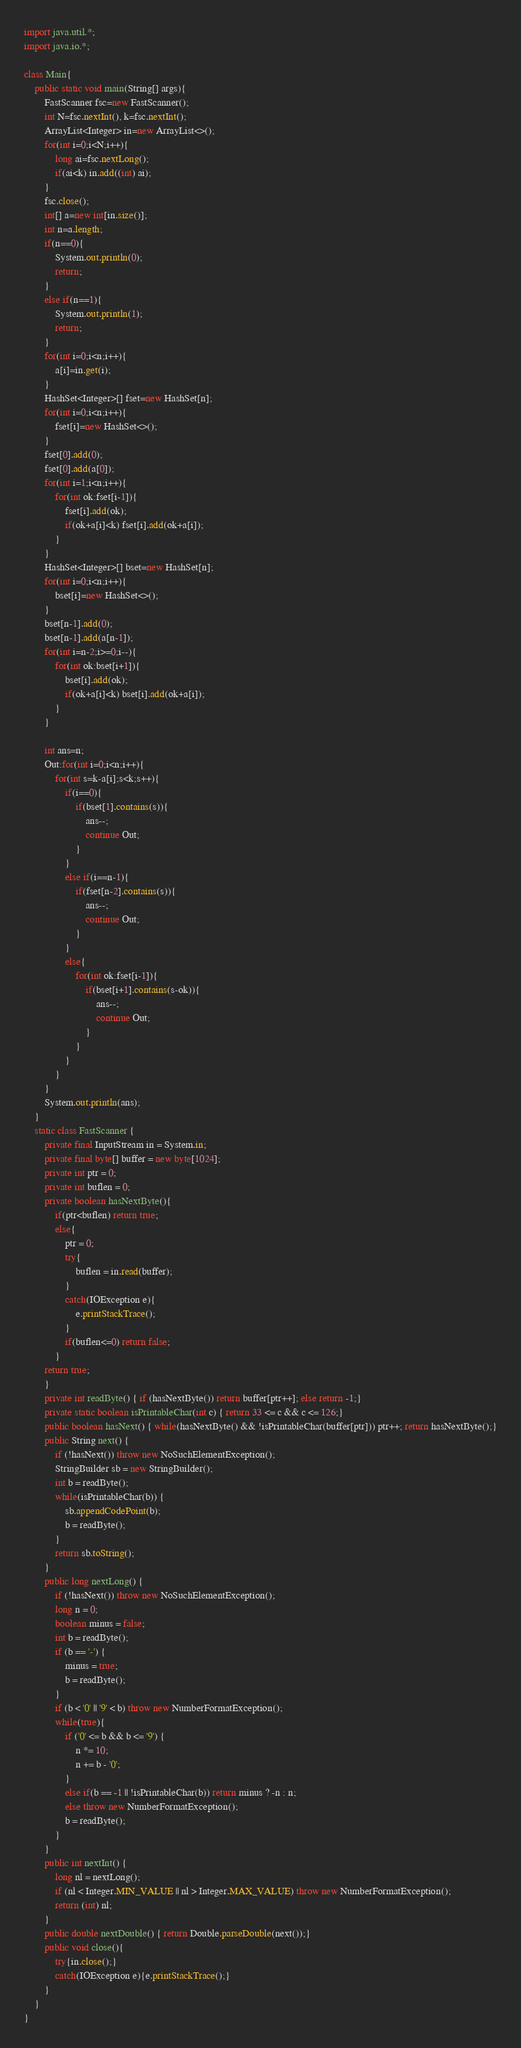<code> <loc_0><loc_0><loc_500><loc_500><_Java_>import java.util.*;
import java.io.*;

class Main{
    public static void main(String[] args){
        FastScanner fsc=new FastScanner();
        int N=fsc.nextInt(), k=fsc.nextInt();
        ArrayList<Integer> in=new ArrayList<>();
        for(int i=0;i<N;i++){
            long ai=fsc.nextLong();
            if(ai<k) in.add((int) ai);
        }
        fsc.close();
        int[] a=new int[in.size()];
        int n=a.length;
        if(n==0){
            System.out.println(0);
            return;
        }
        else if(n==1){
            System.out.println(1);
            return;
        }
        for(int i=0;i<n;i++){
            a[i]=in.get(i);
        }
        HashSet<Integer>[] fset=new HashSet[n];
        for(int i=0;i<n;i++){
            fset[i]=new HashSet<>();
        }
        fset[0].add(0);
        fset[0].add(a[0]);
        for(int i=1;i<n;i++){
            for(int ok:fset[i-1]){
                fset[i].add(ok);
                if(ok+a[i]<k) fset[i].add(ok+a[i]);
            }
        }
        HashSet<Integer>[] bset=new HashSet[n];
        for(int i=0;i<n;i++){
            bset[i]=new HashSet<>();
        }
        bset[n-1].add(0);
        bset[n-1].add(a[n-1]);
        for(int i=n-2;i>=0;i--){
            for(int ok:bset[i+1]){
                bset[i].add(ok);
                if(ok+a[i]<k) bset[i].add(ok+a[i]);
            }
        }

        int ans=n;
        Out:for(int i=0;i<n;i++){
            for(int s=k-a[i];s<k;s++){
                if(i==0){
                    if(bset[1].contains(s)){
                        ans--;
                        continue Out;
                    }
                }
                else if(i==n-1){
                    if(fset[n-2].contains(s)){
                        ans--;
                        continue Out;
                    }
                }
                else{
                    for(int ok:fset[i-1]){
                        if(bset[i+1].contains(s-ok)){
                            ans--;
                            continue Out;
                        }
                    }
                }
            }
        }
        System.out.println(ans);
    }
    static class FastScanner {
        private final InputStream in = System.in;
        private final byte[] buffer = new byte[1024];
        private int ptr = 0;
        private int buflen = 0;
        private boolean hasNextByte(){
            if(ptr<buflen) return true;
            else{
                ptr = 0;
                try{
                    buflen = in.read(buffer);
                }
                catch(IOException e){
                    e.printStackTrace();
                }
                if(buflen<=0) return false;
            }
        return true;
        }
        private int readByte() { if (hasNextByte()) return buffer[ptr++]; else return -1;}
        private static boolean isPrintableChar(int c) { return 33 <= c && c <= 126;}
        public boolean hasNext() { while(hasNextByte() && !isPrintableChar(buffer[ptr])) ptr++; return hasNextByte();}
        public String next() {
            if (!hasNext()) throw new NoSuchElementException();
            StringBuilder sb = new StringBuilder();
            int b = readByte();
            while(isPrintableChar(b)) {
                sb.appendCodePoint(b);
                b = readByte();
            }
            return sb.toString();
        }
        public long nextLong() {
            if (!hasNext()) throw new NoSuchElementException();
            long n = 0;
            boolean minus = false;
            int b = readByte();
            if (b == '-') {
                minus = true;
                b = readByte();
            }
            if (b < '0' || '9' < b) throw new NumberFormatException();
            while(true){
                if ('0' <= b && b <= '9') {
                    n *= 10;
                    n += b - '0';
                }
                else if(b == -1 || !isPrintableChar(b)) return minus ? -n : n;
                else throw new NumberFormatException();
                b = readByte();
            }
        }
        public int nextInt() {
            long nl = nextLong();
            if (nl < Integer.MIN_VALUE || nl > Integer.MAX_VALUE) throw new NumberFormatException();
            return (int) nl;
        }
        public double nextDouble() { return Double.parseDouble(next());}
        public void close(){
            try{in.close();}
            catch(IOException e){e.printStackTrace();}
        }
    }
}
</code> 